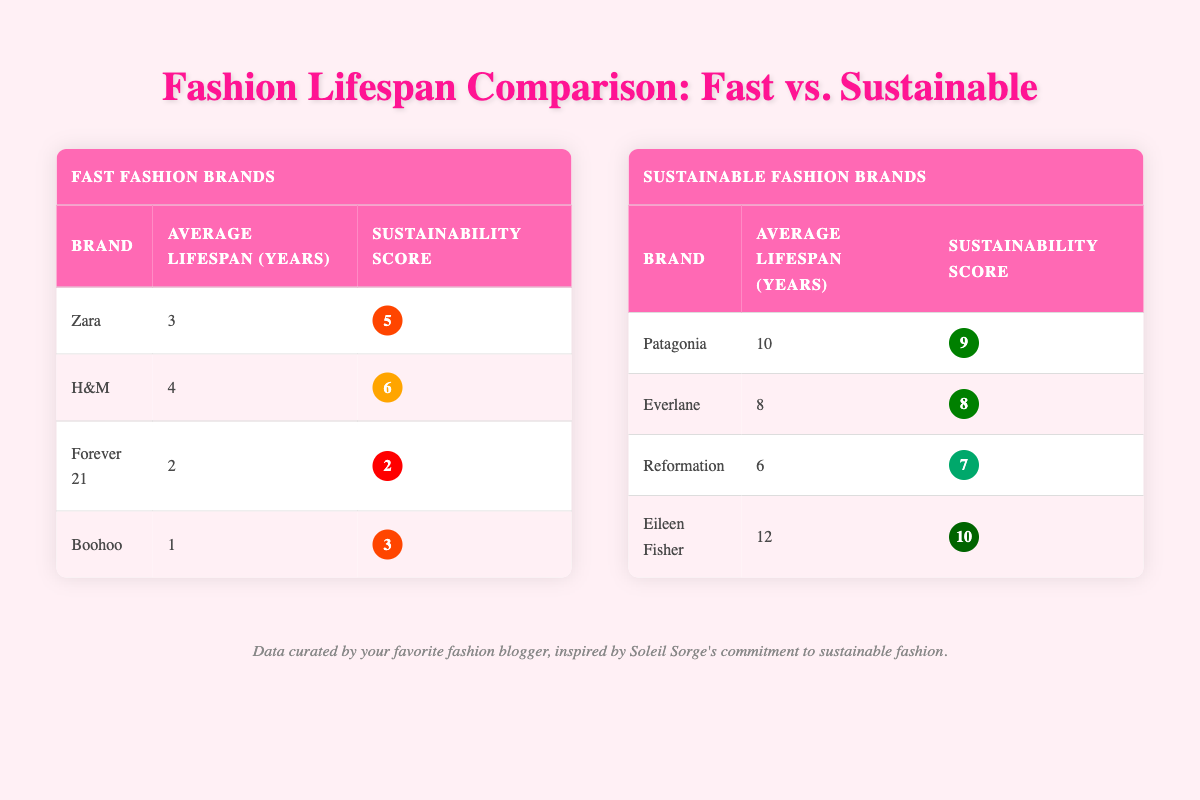What is the average lifespan of Fast Fashion Brands? To find the average lifespan of Fast Fashion Brands, add the average lifespans of Zara (3), H&M (4), Forever 21 (2), and Boohoo (1), which totals to 10. Then, divide by the number of brands (4). Thus, the average is 10/4 = 2.5.
Answer: 2.5 years Which brand has the highest sustainability score in Sustainable Fashion Brands? By examining the sustainability scores of the Sustainable Fashion Brands: Patagonia (9), Everlane (8), Reformation (7), and Eileen Fisher (10), Eileen Fisher has the highest sustainability score of 10.
Answer: Eileen Fisher Is H&M's average lifespan longer than Forever 21’s? H&M's average lifespan is 4 years, while Forever 21's is 2 years. Since 4 is greater than 2, H&M does have a longer average lifespan than Forever 21.
Answer: Yes What is the total average lifespan of all Fast Fashion Brands? To find the total average lifespan of Fast Fashion Brands, add the average lifespans of each: Zara (3) + H&M (4) + Forever 21 (2) + Boohoo (1) = 10 years. Thus, the total average lifespan across these brands is 10 years.
Answer: 10 years Which brand is the most sustainable based on lifespan and sustainability score? The most sustainable brand can be judged by looking at both lifespan and sustainability score. Eileen Fisher has the longest lifespan of 12 years and the highest sustainability score of 10. Thus, it stands out as the most sustainable brand in this comparison.
Answer: Eileen Fisher What is the average lifespan of Sustainable Fashion Brands? To calculate the average lifespan of Sustainable Fashion Brands, sum their average lifespans: Patagonia (10) + Everlane (8) + Reformation (6) + Eileen Fisher (12) = 36 years. Then divide by the number of brands (4), which results in an average lifespan of 36/4 = 9 years.
Answer: 9 years Is it true that all Sustainable Fashion Brands have sustainability scores above 5? Checking the sustainability scores: Patagonia (9), Everlane (8), Reformation (7), and Eileen Fisher (10). All are above 5, which confirms the statement as true.
Answer: Yes What is the difference in average lifespan between Fast Fashion Brands and Sustainable Fashion Brands? Average lifespan of Fast Fashion Brands is 2.5 years, compared to Sustainable Fashion Brands at 9 years. The difference is 9 - 2.5 = 6.5 years, which shows Sustainable Brands have a longer lifespan.
Answer: 6.5 years 